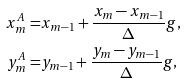<formula> <loc_0><loc_0><loc_500><loc_500>x _ { m } ^ { A } = & { x _ { m - 1 } } + \frac { { { x _ { m } } - { x _ { m - 1 } } } } { \Delta } g , \\ y _ { m } ^ { A } = & { y _ { m - 1 } } + \frac { { { y _ { m } } - { y _ { m - 1 } } } } { \Delta } g ,</formula> 